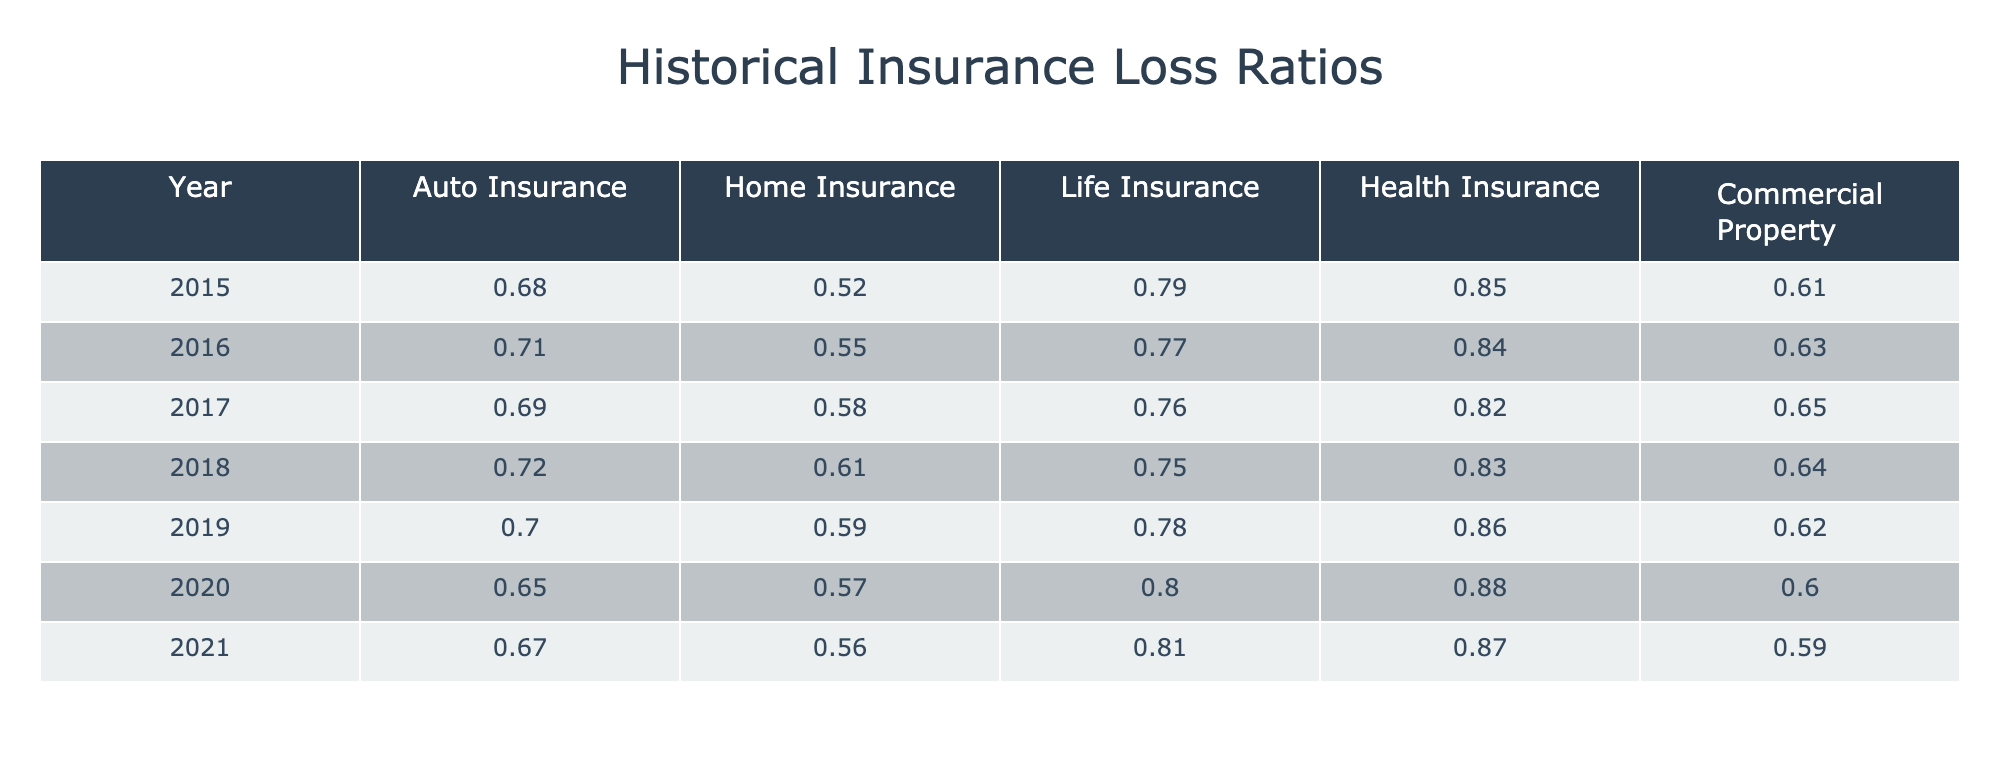What was the loss ratio for Health Insurance in 2016? The table shows that the loss ratio for Health Insurance in the year 2016 is 0.84.
Answer: 0.84 Which year had the lowest loss ratio for Auto Insurance? By examining the table, the lowest loss ratio for Auto Insurance was in 2020 with a value of 0.65.
Answer: 2020 What is the average loss ratio for Commercial Property from 2015 to 2021? The values for Commercial Property from 2015 to 2021 are 0.61, 0.63, 0.65, 0.64, 0.62, and 0.59. The sum of these values is 3.94, and there are 7 data points, so the average is 3.94/7 = 0.5642857, which rounds to 0.56.
Answer: 0.56 Did the loss ratio for Home Insurance increase between 2015 and 2021? Observing the table, the Home Insurance ratios are 0.52 in 2015 and 0.56 in 2021. Since 0.56 is greater than 0.52, it indicates an increase.
Answer: Yes What was the change in the loss ratio for Life Insurance from 2015 to 2021? The loss ratio for Life Insurance decreased from 0.79 in 2015 to 0.81 in 2021. To find the change, we subtract 0.79 from 0.81, yielding a change of 0.02.
Answer: Decreased by 0.02 